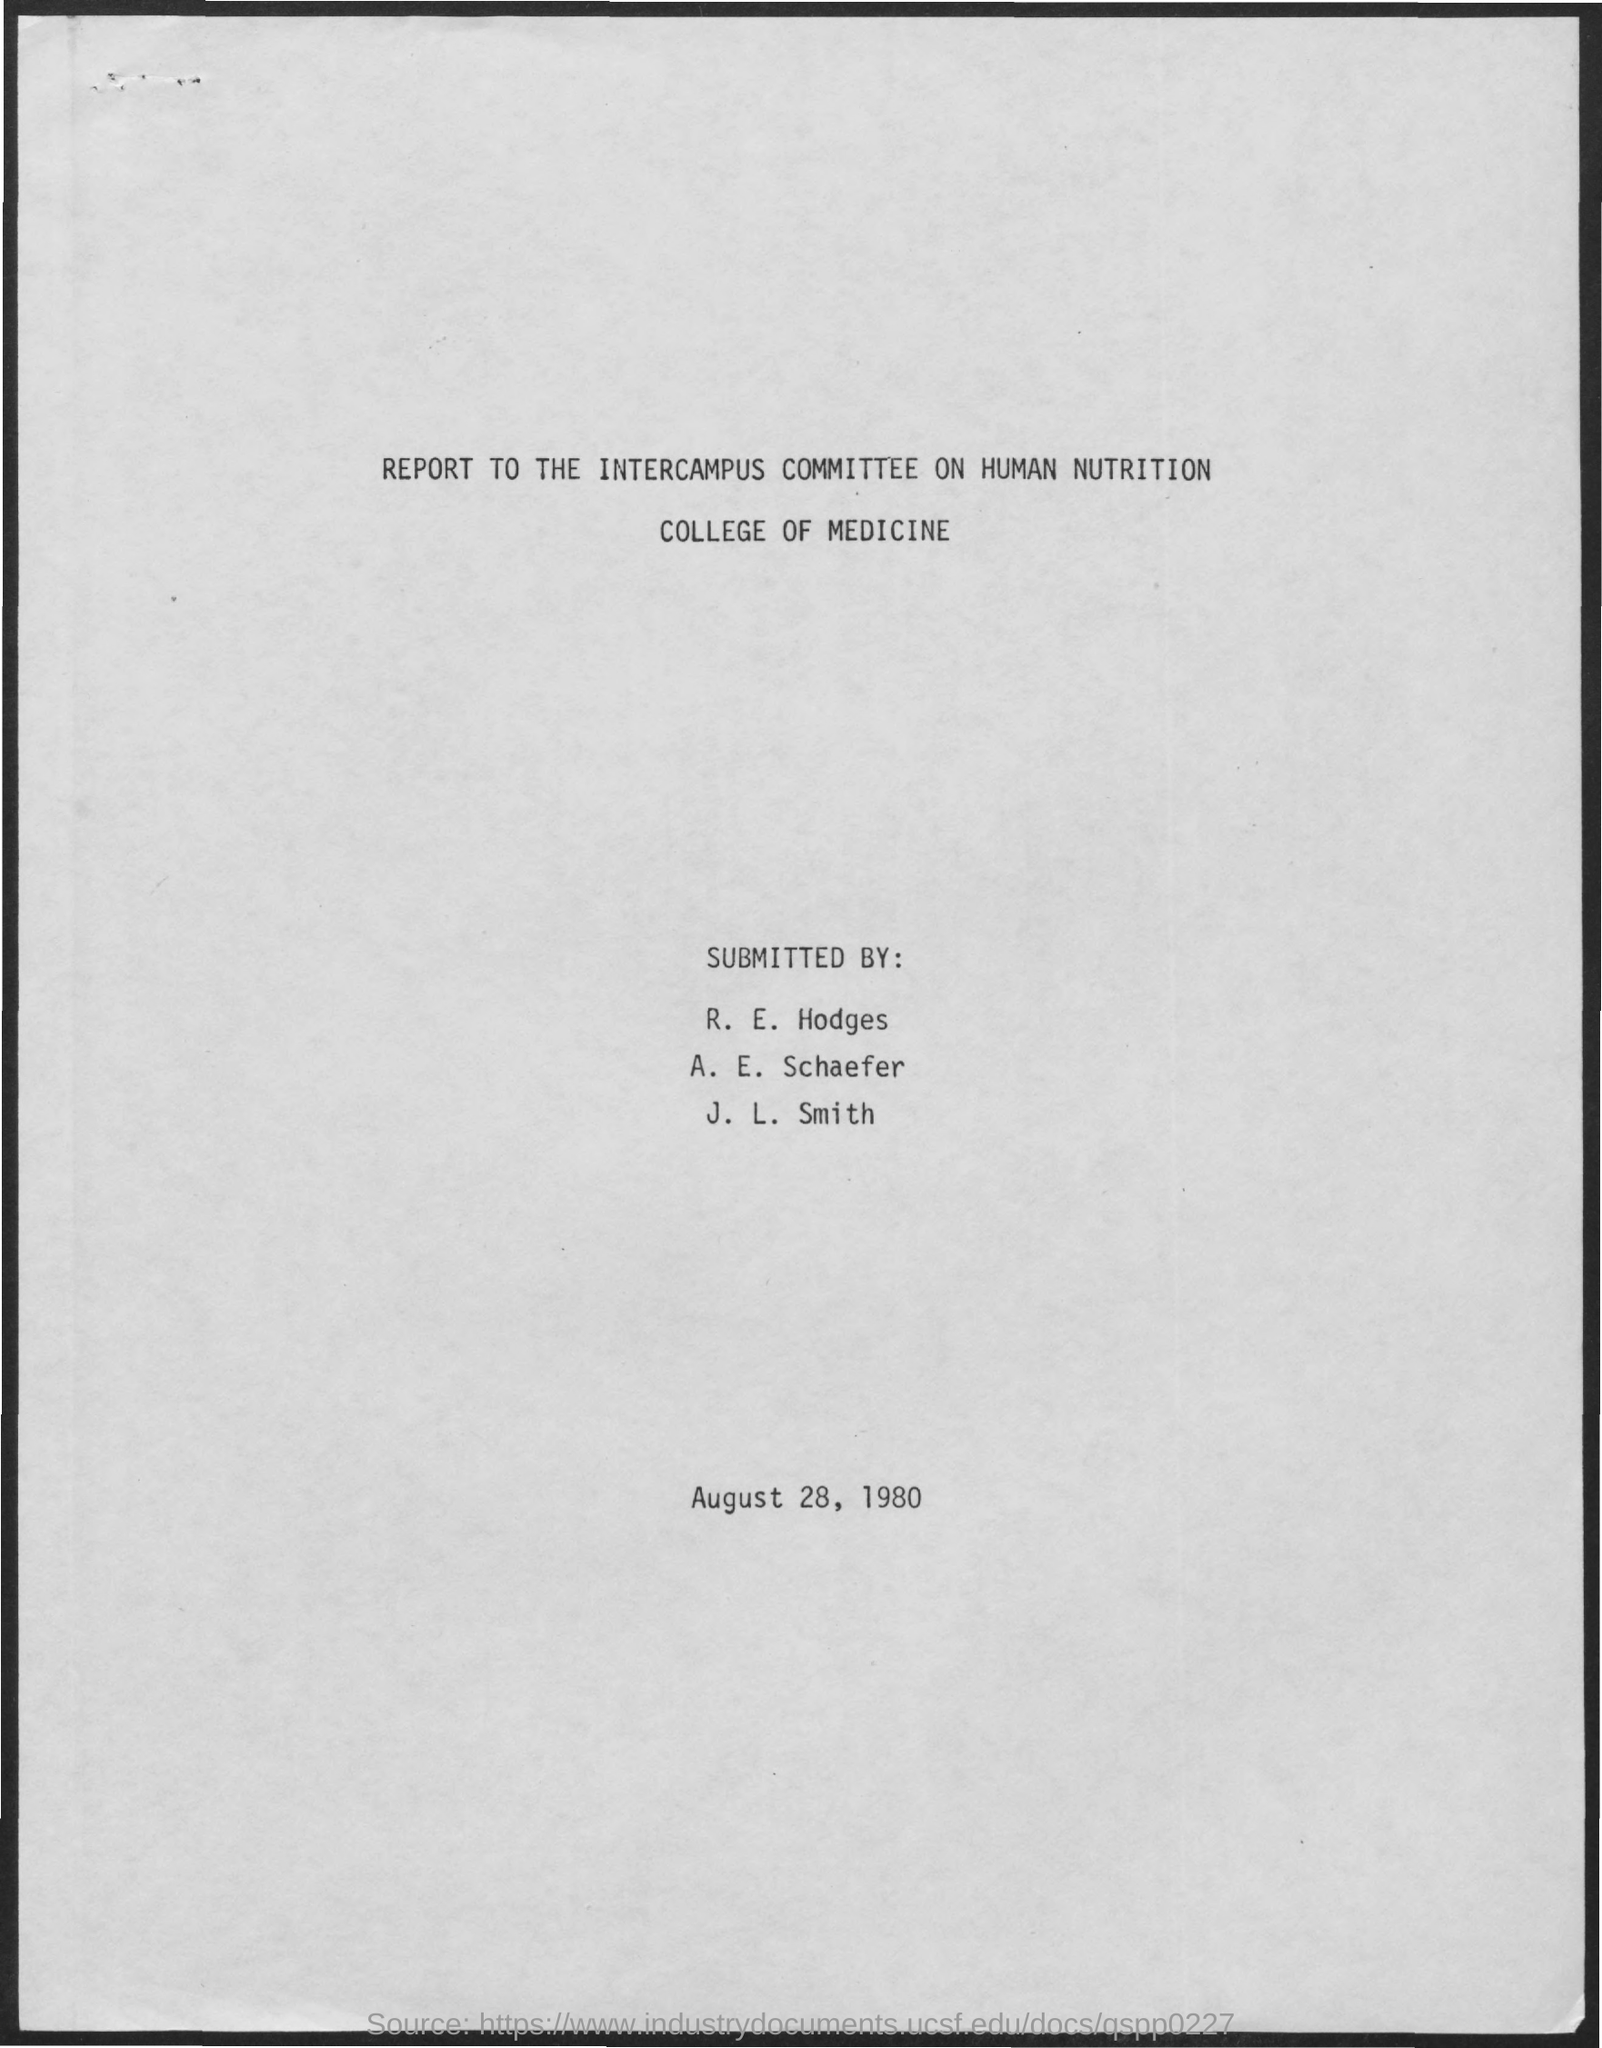List a handful of essential elements in this visual. The report is to be given to an intercampus committee. The college in question is the College of Medicine. The report pertains to the field of human nutrition. The submission of the report took place on August 28, 1980. 